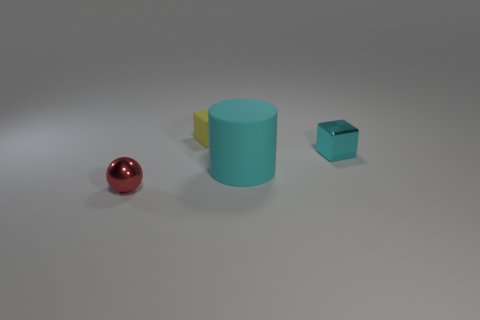How many tiny cyan metallic cylinders are there?
Offer a terse response. 0. How many red balls are made of the same material as the small cyan thing?
Ensure brevity in your answer.  1. There is another thing that is the same shape as the tiny cyan shiny object; what size is it?
Your response must be concise. Small. What is the material of the cyan cylinder?
Offer a terse response. Rubber. What is the thing behind the shiny cube that is on the right side of the tiny cube that is left of the tiny cyan metal cube made of?
Give a very brief answer. Rubber. Is there any other thing that has the same shape as the red object?
Offer a terse response. No. What color is the other object that is the same shape as the yellow matte object?
Provide a succinct answer. Cyan. Does the tiny metallic thing that is behind the tiny red metal object have the same color as the large matte cylinder on the left side of the small cyan metallic block?
Ensure brevity in your answer.  Yes. Are there more yellow objects that are behind the cyan rubber cylinder than tiny blue rubber spheres?
Make the answer very short. Yes. How many other objects are the same size as the cyan matte cylinder?
Give a very brief answer. 0. 